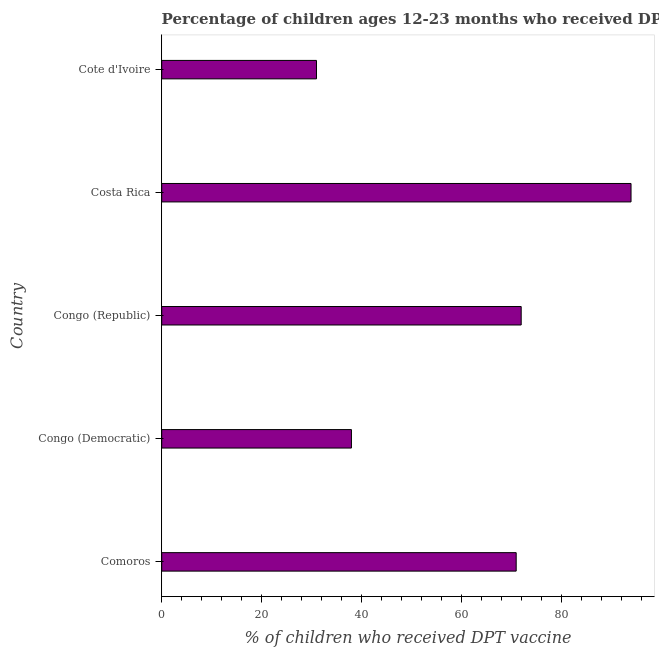What is the title of the graph?
Ensure brevity in your answer.  Percentage of children ages 12-23 months who received DPT vaccinations in 1987. What is the label or title of the X-axis?
Ensure brevity in your answer.  % of children who received DPT vaccine. What is the label or title of the Y-axis?
Offer a very short reply. Country. What is the percentage of children who received dpt vaccine in Costa Rica?
Your answer should be very brief. 94. Across all countries, what is the maximum percentage of children who received dpt vaccine?
Your response must be concise. 94. In which country was the percentage of children who received dpt vaccine minimum?
Provide a succinct answer. Cote d'Ivoire. What is the sum of the percentage of children who received dpt vaccine?
Provide a succinct answer. 306. What is the difference between the percentage of children who received dpt vaccine in Comoros and Congo (Republic)?
Keep it short and to the point. -1. What is the average percentage of children who received dpt vaccine per country?
Offer a very short reply. 61.2. What is the ratio of the percentage of children who received dpt vaccine in Comoros to that in Congo (Republic)?
Ensure brevity in your answer.  0.99. Is the percentage of children who received dpt vaccine in Congo (Democratic) less than that in Cote d'Ivoire?
Give a very brief answer. No. Is the sum of the percentage of children who received dpt vaccine in Comoros and Cote d'Ivoire greater than the maximum percentage of children who received dpt vaccine across all countries?
Ensure brevity in your answer.  Yes. What is the difference between the highest and the lowest percentage of children who received dpt vaccine?
Your answer should be compact. 63. In how many countries, is the percentage of children who received dpt vaccine greater than the average percentage of children who received dpt vaccine taken over all countries?
Offer a terse response. 3. How many bars are there?
Keep it short and to the point. 5. What is the difference between two consecutive major ticks on the X-axis?
Your response must be concise. 20. Are the values on the major ticks of X-axis written in scientific E-notation?
Give a very brief answer. No. What is the % of children who received DPT vaccine in Congo (Democratic)?
Ensure brevity in your answer.  38. What is the % of children who received DPT vaccine in Congo (Republic)?
Offer a very short reply. 72. What is the % of children who received DPT vaccine in Costa Rica?
Ensure brevity in your answer.  94. What is the difference between the % of children who received DPT vaccine in Comoros and Cote d'Ivoire?
Your response must be concise. 40. What is the difference between the % of children who received DPT vaccine in Congo (Democratic) and Congo (Republic)?
Offer a terse response. -34. What is the difference between the % of children who received DPT vaccine in Congo (Democratic) and Costa Rica?
Provide a short and direct response. -56. What is the difference between the % of children who received DPT vaccine in Congo (Republic) and Costa Rica?
Give a very brief answer. -22. What is the difference between the % of children who received DPT vaccine in Congo (Republic) and Cote d'Ivoire?
Give a very brief answer. 41. What is the ratio of the % of children who received DPT vaccine in Comoros to that in Congo (Democratic)?
Ensure brevity in your answer.  1.87. What is the ratio of the % of children who received DPT vaccine in Comoros to that in Congo (Republic)?
Give a very brief answer. 0.99. What is the ratio of the % of children who received DPT vaccine in Comoros to that in Costa Rica?
Give a very brief answer. 0.76. What is the ratio of the % of children who received DPT vaccine in Comoros to that in Cote d'Ivoire?
Ensure brevity in your answer.  2.29. What is the ratio of the % of children who received DPT vaccine in Congo (Democratic) to that in Congo (Republic)?
Keep it short and to the point. 0.53. What is the ratio of the % of children who received DPT vaccine in Congo (Democratic) to that in Costa Rica?
Make the answer very short. 0.4. What is the ratio of the % of children who received DPT vaccine in Congo (Democratic) to that in Cote d'Ivoire?
Make the answer very short. 1.23. What is the ratio of the % of children who received DPT vaccine in Congo (Republic) to that in Costa Rica?
Keep it short and to the point. 0.77. What is the ratio of the % of children who received DPT vaccine in Congo (Republic) to that in Cote d'Ivoire?
Provide a succinct answer. 2.32. What is the ratio of the % of children who received DPT vaccine in Costa Rica to that in Cote d'Ivoire?
Offer a terse response. 3.03. 